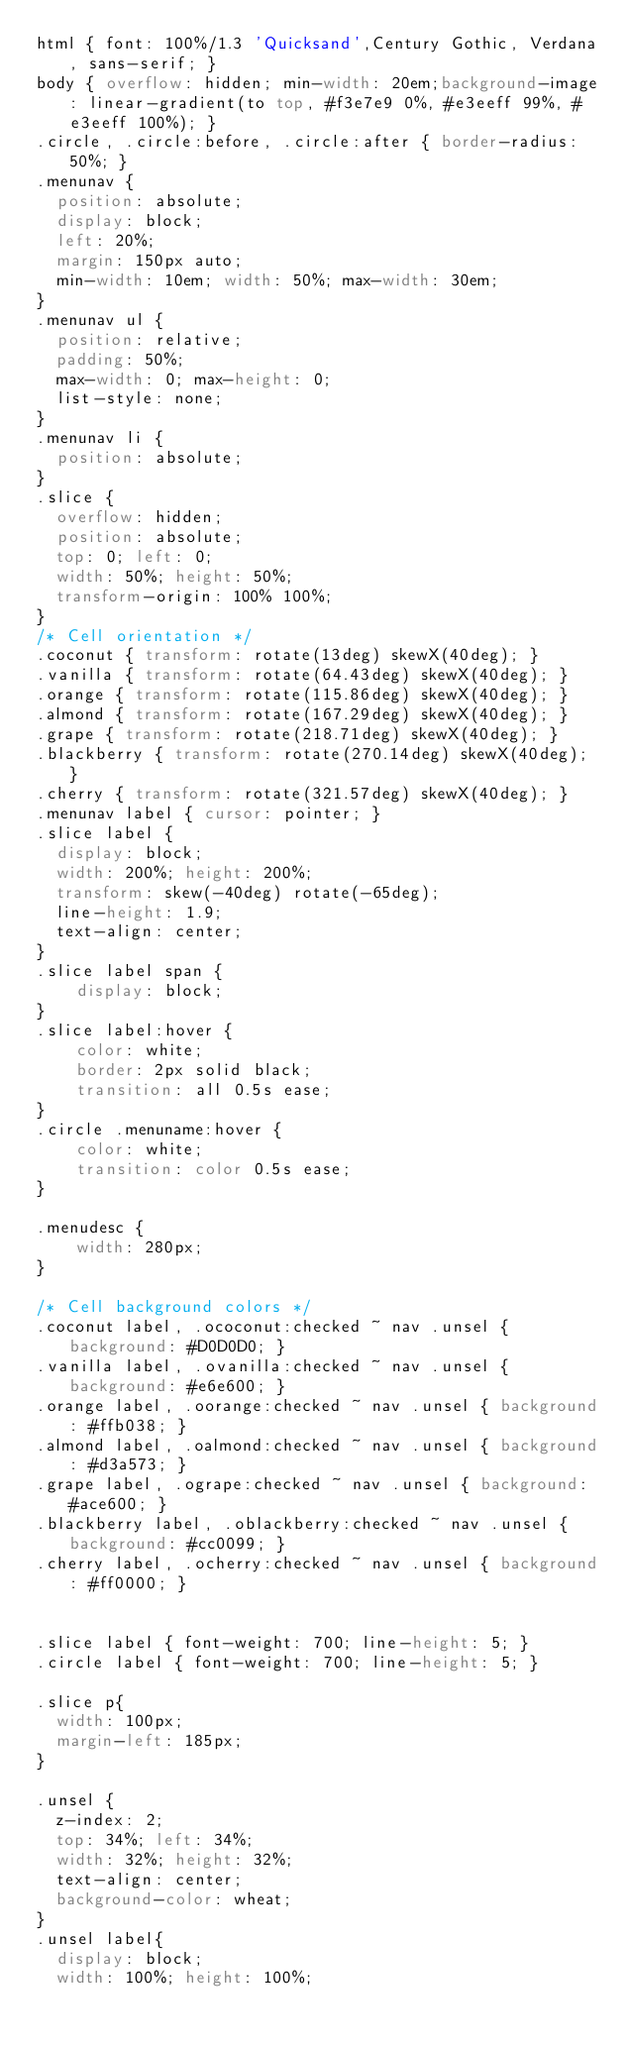<code> <loc_0><loc_0><loc_500><loc_500><_CSS_>html { font: 100%/1.3 'Quicksand',Century Gothic, Verdana, sans-serif; }
body { overflow: hidden; min-width: 20em;background-image: linear-gradient(to top, #f3e7e9 0%, #e3eeff 99%, #e3eeff 100%); }
.circle, .circle:before, .circle:after { border-radius: 50%; }
.menunav {
  position: absolute;
  display: block;
  left: 20%;
  margin: 150px auto;
  min-width: 10em; width: 50%; max-width: 30em;
}
.menunav ul {
  position: relative;
  padding: 50%;
  max-width: 0; max-height: 0;
  list-style: none;
}
.menunav li {
  position: absolute;
}
.slice {
  overflow: hidden;
  position: absolute;
  top: 0; left: 0;
  width: 50%; height: 50%;
  transform-origin: 100% 100%;
}
/* Cell orientation */
.coconut { transform: rotate(13deg) skewX(40deg); }
.vanilla { transform: rotate(64.43deg) skewX(40deg); }
.orange { transform: rotate(115.86deg) skewX(40deg); }
.almond { transform: rotate(167.29deg) skewX(40deg); }
.grape { transform: rotate(218.71deg) skewX(40deg); }
.blackberry { transform: rotate(270.14deg) skewX(40deg); }
.cherry { transform: rotate(321.57deg) skewX(40deg); }
.menunav label { cursor: pointer; }
.slice label {
  display: block;
  width: 200%; height: 200%;
  transform: skew(-40deg) rotate(-65deg);
  line-height: 1.9;
  text-align: center;
}
.slice label span {
	display: block;
}
.slice label:hover {
	color: white;
	border: 2px solid black;
	transition: all 0.5s ease;
}
.circle .menuname:hover {
	color: white;
	transition: color 0.5s ease;
}

.menudesc {
	width: 280px;
}

/* Cell background colors */
.coconut label, .ococonut:checked ~ nav .unsel { background: #D0D0D0; }
.vanilla label, .ovanilla:checked ~ nav .unsel { background: #e6e600; }
.orange label, .oorange:checked ~ nav .unsel { background: #ffb038; }
.almond label, .oalmond:checked ~ nav .unsel { background: #d3a573; }
.grape label, .ogrape:checked ~ nav .unsel { background: #ace600; }
.blackberry label, .oblackberry:checked ~ nav .unsel { background: #cc0099; }
.cherry label, .ocherry:checked ~ nav .unsel { background: #ff0000; }


.slice label { font-weight: 700; line-height: 5; }
.circle label { font-weight: 700; line-height: 5; }

.slice p{
  width: 100px;
  margin-left: 185px;
}

.unsel {
  z-index: 2;
  top: 34%; left: 34%;
  width: 32%; height: 32%;
  text-align: center;
  background-color: wheat;
}
.unsel label{
  display: block;
  width: 100%; height: 100%;</code> 